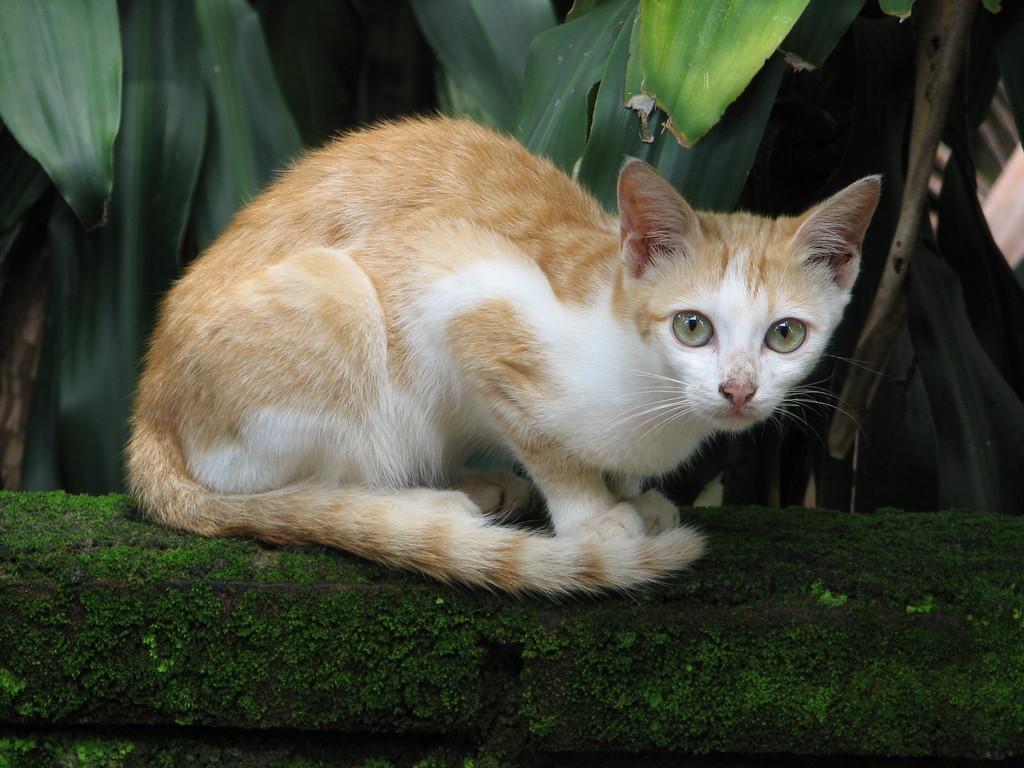How would you summarize this image in a sentence or two? In this picture there is a cat sitting and we can see algae. In the background of the image we can see leaves. 